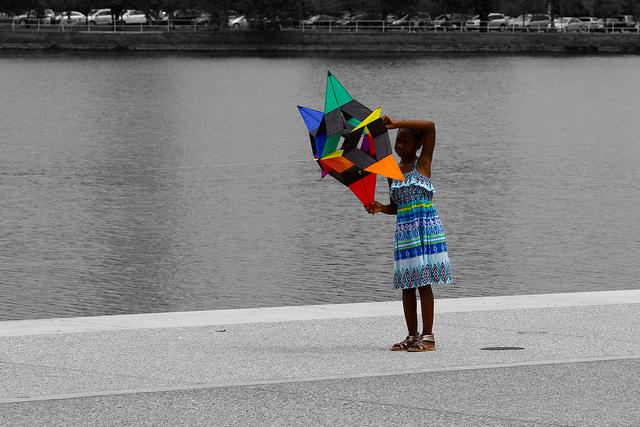Where does the girl want the toy she holds to go?

Choices:
A) skyward
B) nowhere
C) down
D) sideways skyward 